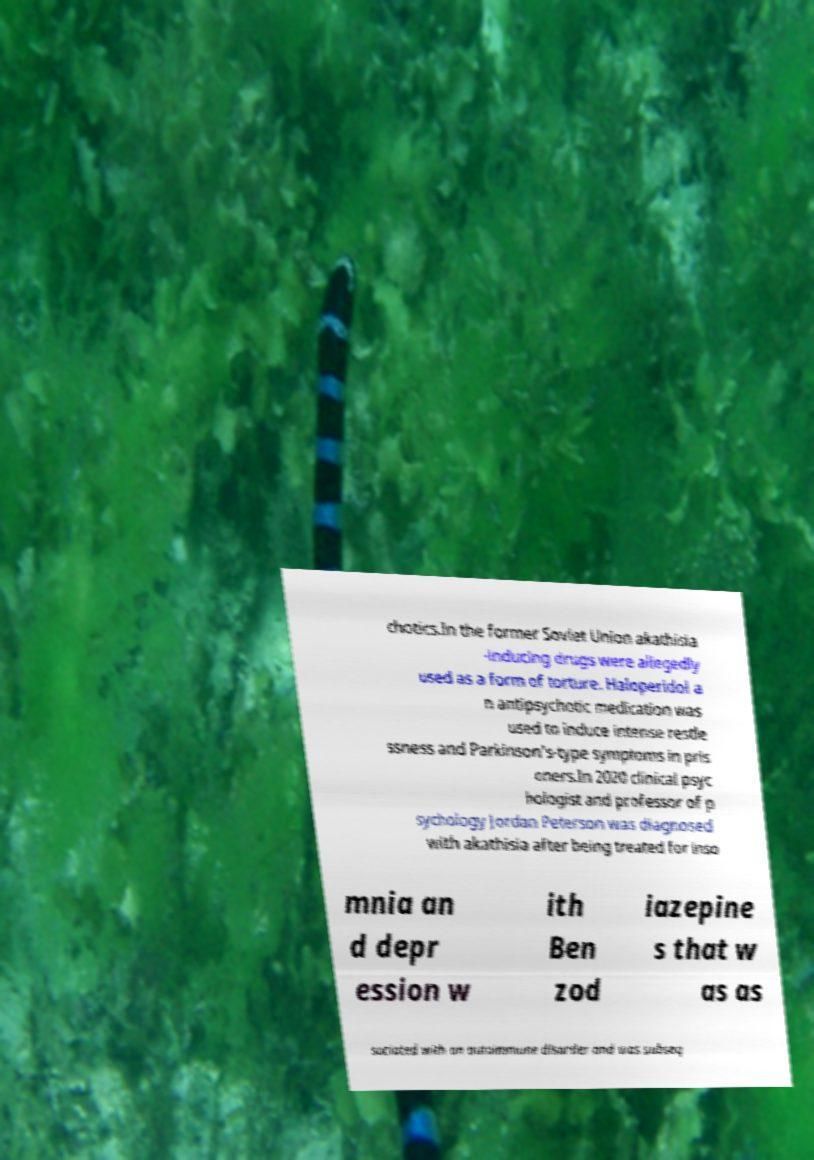Please identify and transcribe the text found in this image. chotics.In the former Soviet Union akathisia -inducing drugs were allegedly used as a form of torture. Haloperidol a n antipsychotic medication was used to induce intense restle ssness and Parkinson's-type symptoms in pris oners.In 2020 clinical psyc hologist and professor of p sychology Jordan Peterson was diagnosed with akathisia after being treated for inso mnia an d depr ession w ith Ben zod iazepine s that w as as sociated with an autoimmune disorder and was subseq 